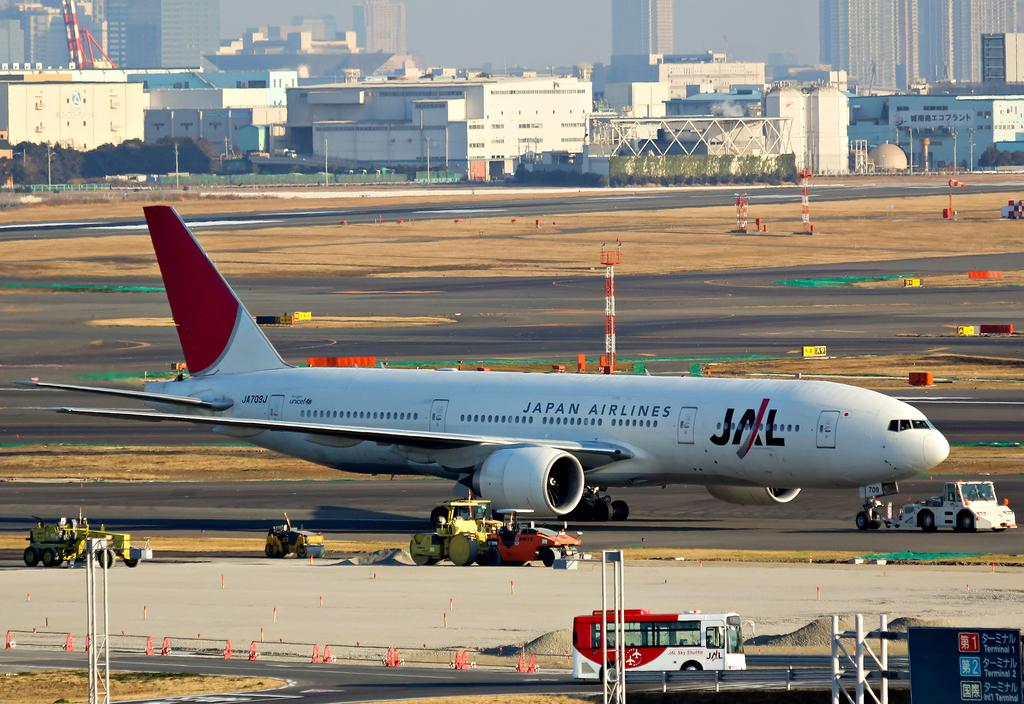<image>
Render a clear and concise summary of the photo. the letters JAL are on the side of the plane 